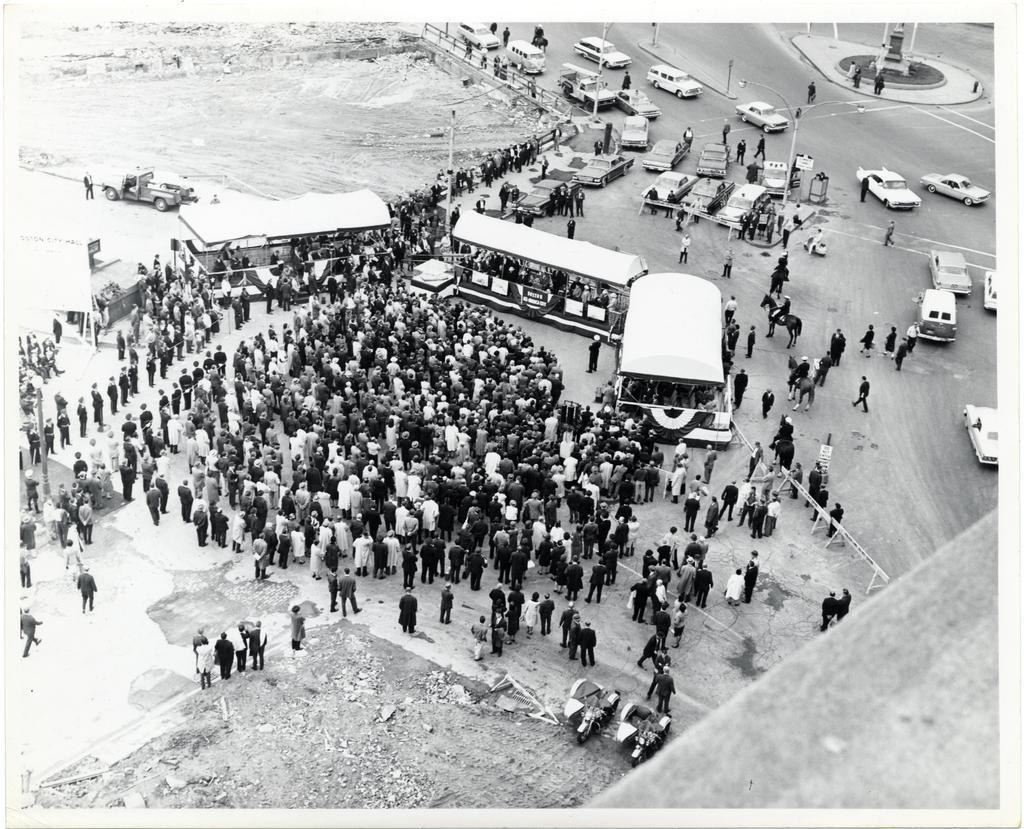Could you give a brief overview of what you see in this image? It is a black and white image. In this image we can see many people. We can also see the vehicles on the road. We can see the tents for shelter. We can see the barrier, fence and also the poles. 